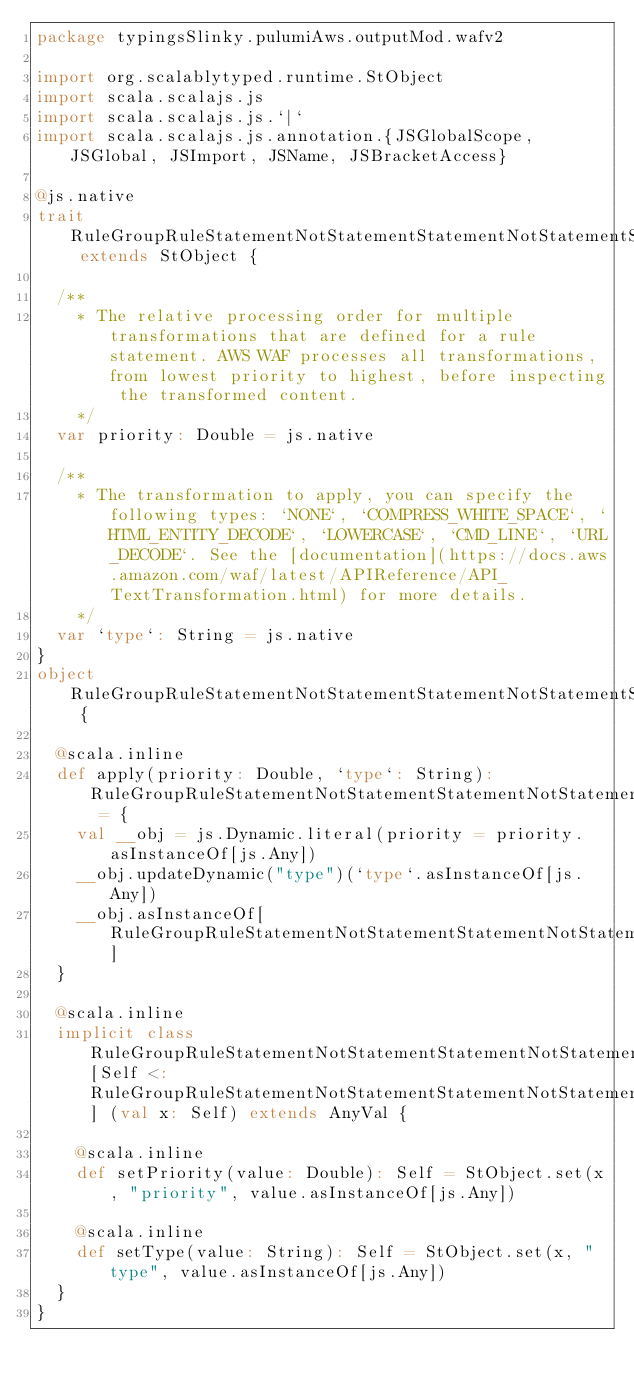<code> <loc_0><loc_0><loc_500><loc_500><_Scala_>package typingsSlinky.pulumiAws.outputMod.wafv2

import org.scalablytyped.runtime.StObject
import scala.scalajs.js
import scala.scalajs.js.`|`
import scala.scalajs.js.annotation.{JSGlobalScope, JSGlobal, JSImport, JSName, JSBracketAccess}

@js.native
trait RuleGroupRuleStatementNotStatementStatementNotStatementStatementSizeConstraintStatementTextTransformation extends StObject {
  
  /**
    * The relative processing order for multiple transformations that are defined for a rule statement. AWS WAF processes all transformations, from lowest priority to highest, before inspecting the transformed content.
    */
  var priority: Double = js.native
  
  /**
    * The transformation to apply, you can specify the following types: `NONE`, `COMPRESS_WHITE_SPACE`, `HTML_ENTITY_DECODE`, `LOWERCASE`, `CMD_LINE`, `URL_DECODE`. See the [documentation](https://docs.aws.amazon.com/waf/latest/APIReference/API_TextTransformation.html) for more details.
    */
  var `type`: String = js.native
}
object RuleGroupRuleStatementNotStatementStatementNotStatementStatementSizeConstraintStatementTextTransformation {
  
  @scala.inline
  def apply(priority: Double, `type`: String): RuleGroupRuleStatementNotStatementStatementNotStatementStatementSizeConstraintStatementTextTransformation = {
    val __obj = js.Dynamic.literal(priority = priority.asInstanceOf[js.Any])
    __obj.updateDynamic("type")(`type`.asInstanceOf[js.Any])
    __obj.asInstanceOf[RuleGroupRuleStatementNotStatementStatementNotStatementStatementSizeConstraintStatementTextTransformation]
  }
  
  @scala.inline
  implicit class RuleGroupRuleStatementNotStatementStatementNotStatementStatementSizeConstraintStatementTextTransformationMutableBuilder[Self <: RuleGroupRuleStatementNotStatementStatementNotStatementStatementSizeConstraintStatementTextTransformation] (val x: Self) extends AnyVal {
    
    @scala.inline
    def setPriority(value: Double): Self = StObject.set(x, "priority", value.asInstanceOf[js.Any])
    
    @scala.inline
    def setType(value: String): Self = StObject.set(x, "type", value.asInstanceOf[js.Any])
  }
}
</code> 